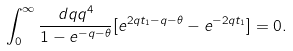Convert formula to latex. <formula><loc_0><loc_0><loc_500><loc_500>\int _ { 0 } ^ { \infty } \frac { d q q ^ { 4 } } { 1 - e ^ { - q - \theta } } [ e ^ { 2 q t _ { 1 } - q - \theta } - e ^ { - 2 q t _ { 1 } } ] = 0 .</formula> 